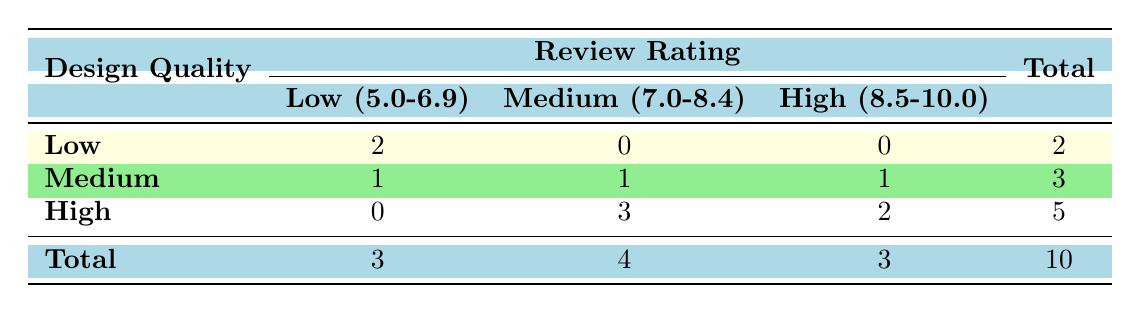What is the total number of movies with Low design quality? By looking at the Low design quality row, we can see there are 2 entries with Low review ratings. The total count is also shown at the end of the row, which is 2.
Answer: 2 How many movies received a Medium review rating and have High design quality? In the High design quality row, we can see there is 1 movie with a Medium review rating listed. Therefore, the total count is 1.
Answer: 1 What is the total number of movies with High design quality? The total for High design quality is listed at the bottom of that column, which sums up all entries under High design quality (0 + 3 + 2). Therefore, the total count is 5.
Answer: 5 Is it true that all Low design quality movies have a review rating below 7.0? Yes, examining the Low design quality row, we see both movies listed have review ratings of 5.7 and 6.0, which are indeed below 7.0.
Answer: Yes How does the number of Medium-rated movies compare between Low and High design qualities? The Low design quality has 0 movies with a Medium review rating. In contrast, the High design quality has 3 movies with a Medium rating. Therefore, the difference is 3 - 0 = 3.
Answer: 3 What is the average review rating of movies with Medium design quality? The review ratings for Medium design quality are 6.5 (Birds of Prey), 8.6 (Parasite), and 9.0 (The Dark Knight). To find the average, sum these ratings (6.5 + 8.6 + 9.0 = 24.1) and then divide by the number of movies (24.1 / 3 ≈ 8.03).
Answer: 8.03 How many movies have a review rating greater than 8.5? Looking at the table, the movies with review ratings greater than 8.5 are Inception (9.0), Interstellar (8.6), and one movie with a High rating (9.0), summing up to 3 in total.
Answer: 3 What percentage of Medium design quality movies have High review ratings? There are 3 Medium design quality movies. Out of these, 1 has a High rating (Interstellar). So, the percentage is (1/3) * 100 ≈ 33.33%.
Answer: 33.33% 